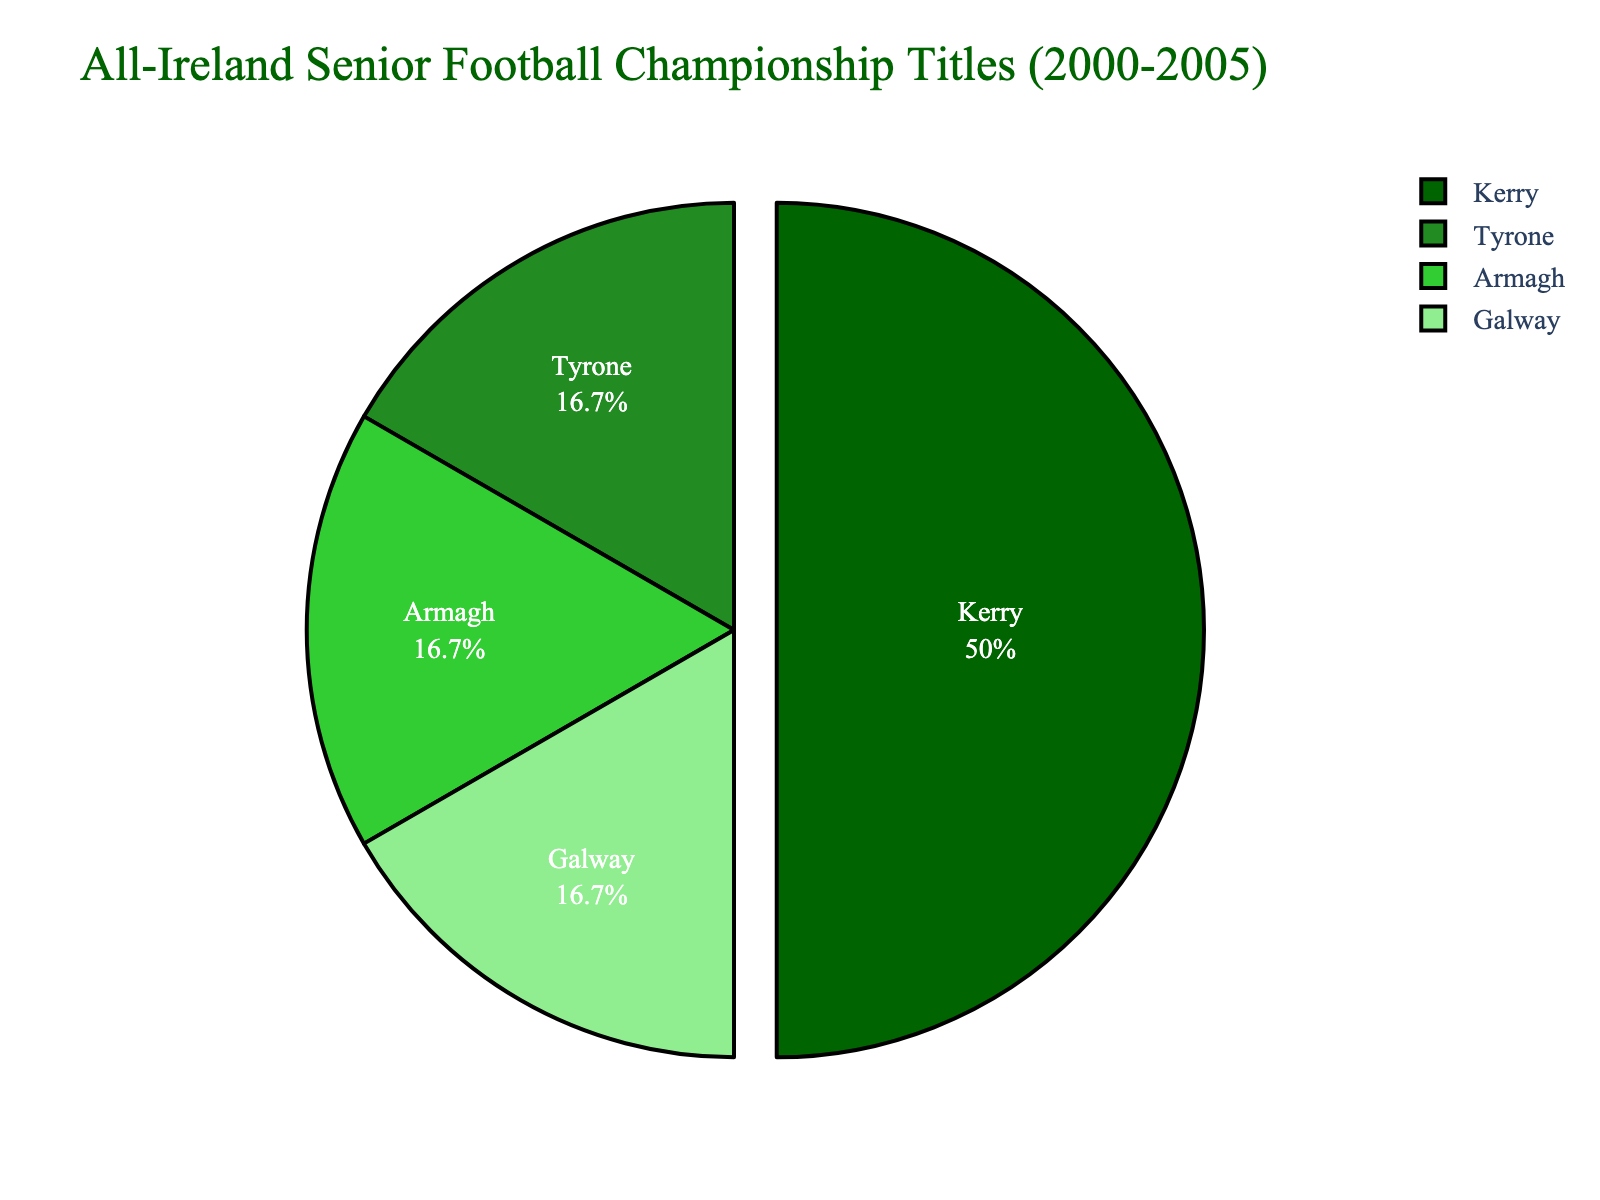Which county won the most titles between 2000 and 2005? By looking at the pie chart, we can see that Kerry has the largest slice, indicating it won the most titles. Kerry won 3 titles between 2000 and 2005.
Answer: Kerry How many titles did the remaining counties win in total? We see from the pie chart that Tyrone, Armagh, and Galway each won 1 title. Summing these gives 1 + 1 + 1 = 3.
Answer: 3 What percentage of the total titles did Kerry win? The pie chart shows titles won and percentage distribution for each county. Kerry's slice is marked with its percentage, which is 50%.
Answer: 50% How do Tyrone and Galway compare in terms of titles won? Looking at the pie chart, both Tyrone and Galway have the same size slices, indicating each won 1 title.
Answer: Equal If Kerry had won 4 titles instead of 3, how would the percentage of total titles for Kerry change? Initially, Kerry won 3 titles out of 6, which is 50%. If Kerry had won 4 out of 7 total titles, the percentage would be (4/7) * 100 ≈ 57.14%.
Answer: 57.14% Which county has the second-largest slice in the pie chart? By examining the pie chart, after Kerry's largest slice, the remaining slices are of equal size for Tyrone, Armagh, and Galway. Any of these can be considered the "second-largest" since they are equal.
Answer: Tyrone/Armagh/Galway What is the difference in the number of titles won by Kerry and Armagh? Kerry won 3 titles, and Armagh won 1. The difference is 3 - 1 = 2.
Answer: 2 What color represents the county with the fewest titles? The colors in the pie chart vary only by county, and Tyrone, Armagh, and Galway each won 1 title, sharing the fewest; their corresponding colors will represent the smallest portion. Each has a distinct color.
Answer: Various colors (one each for Tyrone, Armagh, Galway) If another county had won 1 title in this period, what would be the new total number of titles and the adjusted percentage for each slice? Adding another county with 1 title makes the total titles 7. Kerry's new percentage would be (3/7) * 100 ≈ 42.86%, and each of the others (Tyrone, Armagh, Galway, and the new county) would be (1/7) * 100 ≈ 14.29%.
Answer: 7, Kerry: 42.86%, Others: 14.29% How is the county with the most titles visually distinguished in the chart? The pie chart uses an exploded or "pulled-out" effect for Kerry, separating it slightly from the rest for emphasis.
Answer: Pulled-out effect 